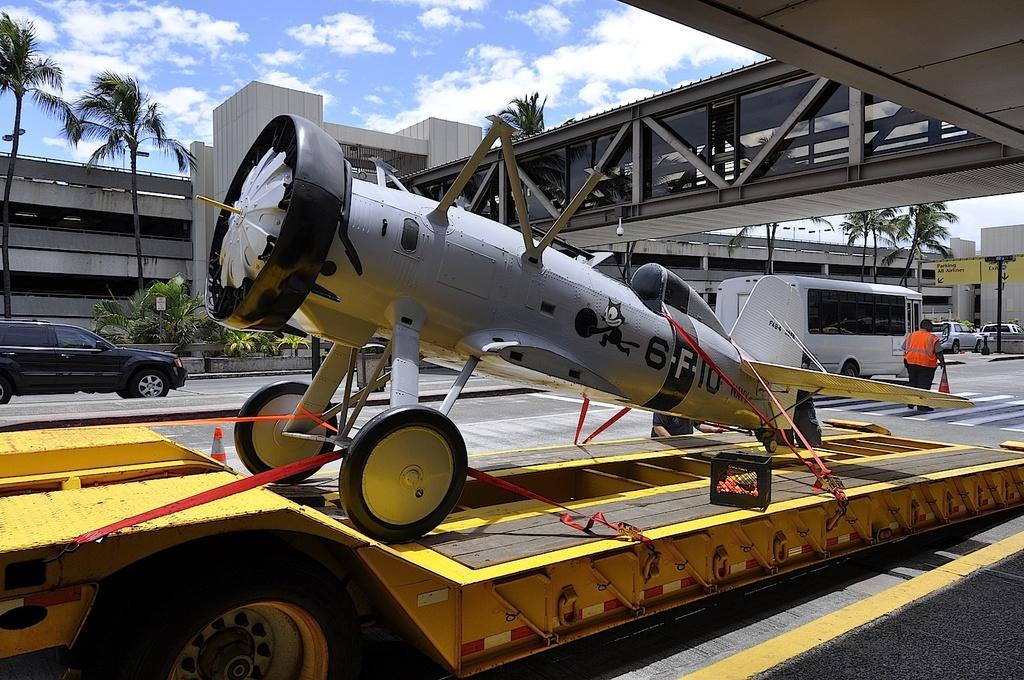<image>
Offer a succinct explanation of the picture presented. A small device has a picture of Felix the cat and 6F10 written on it. 